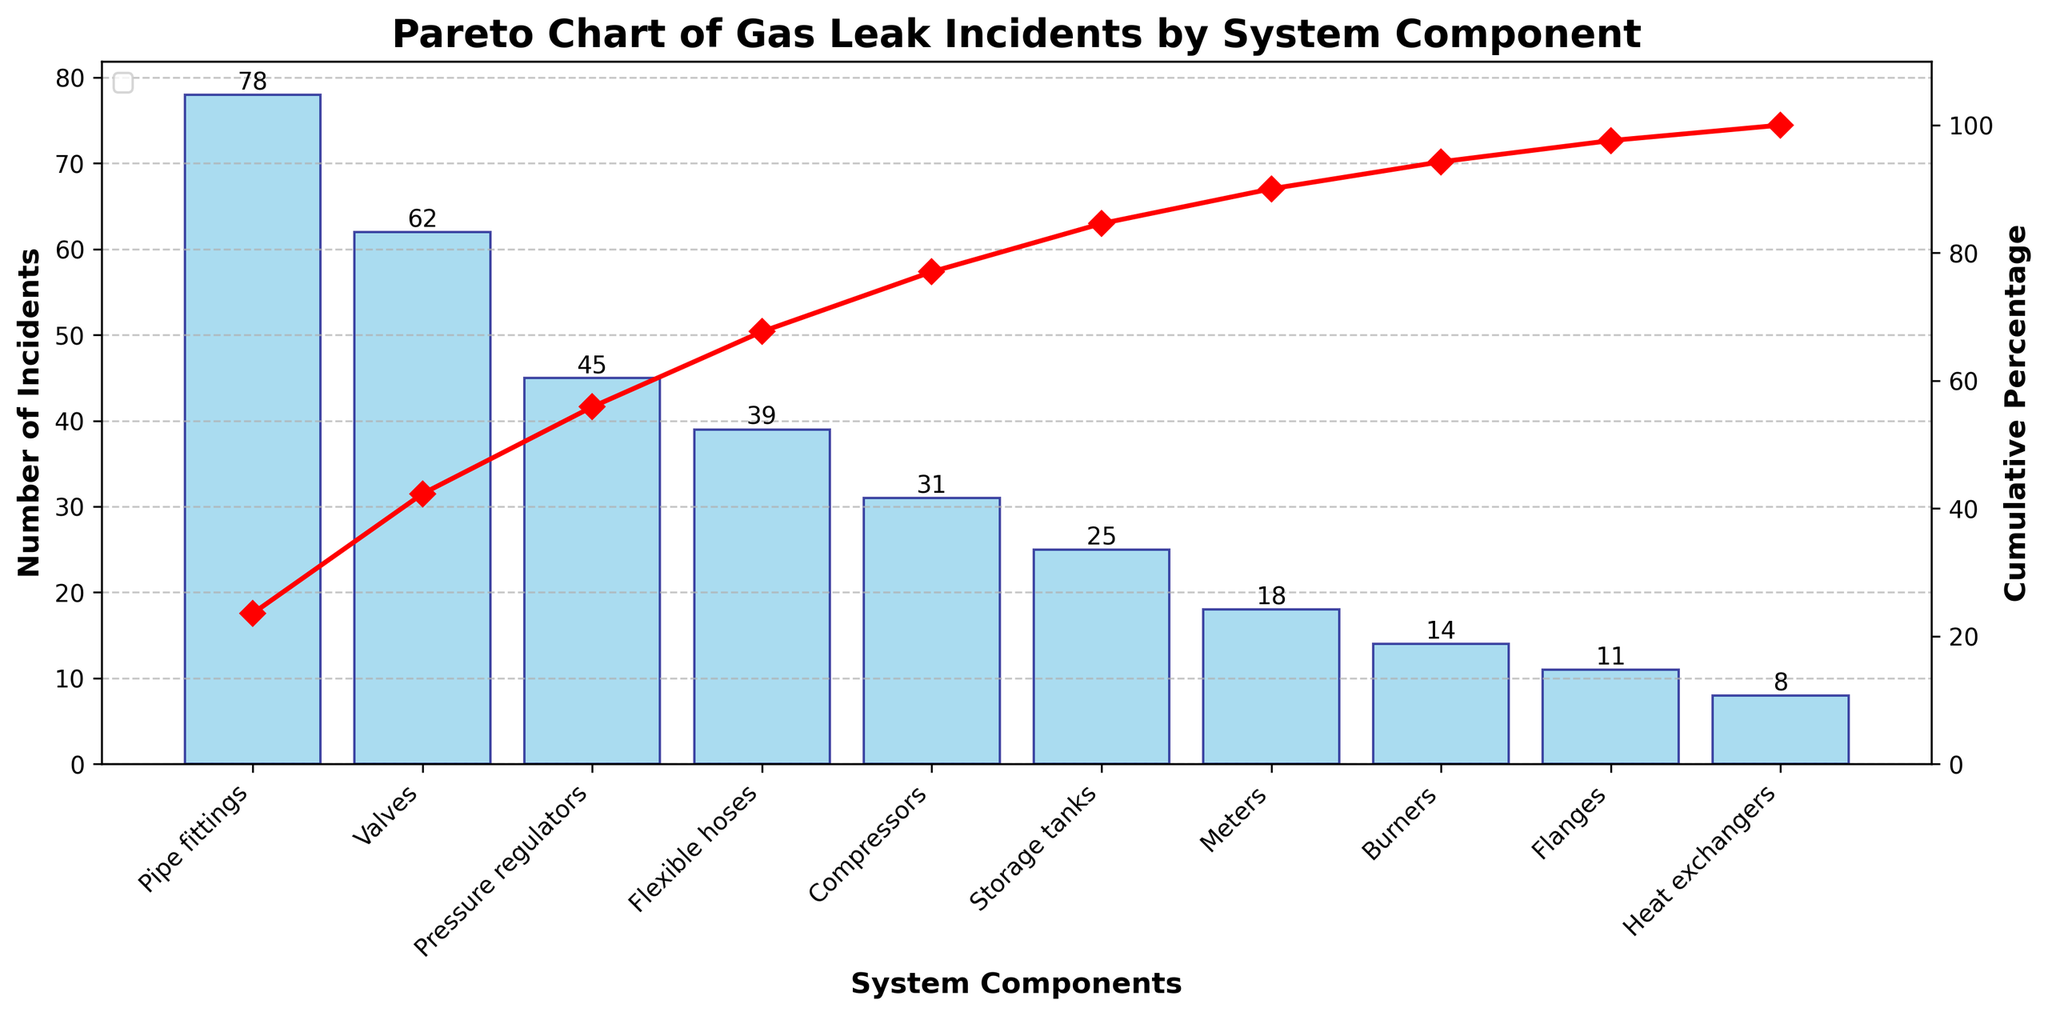What's the title of the chart? The title is usually displayed at the top of the chart. In this case, it reads "Pareto Chart of Gas Leak Incidents by System Component".
Answer: Pareto Chart of Gas Leak Incidents by System Component Which system component has the highest number of incidents? To find this, look at the highest bar in the bar chart. The bar representing "Pipe fittings" is the tallest.
Answer: Pipe fittings What is the number of incidents for Valves? Locate the bar for "Valves" on the x-axis and note the value at the top of the bar. It shows "62".
Answer: 62 What's the cumulative percentage after the third component? The cumulative percentage line shows the accumulation as each component is added. After the third component (Pressure regulators), the line shows approximately 74.3%.
Answer: 74.3% Are there more incidents in Flexible hoses than in Compressors? Compare the heights of the bars for "Flexible hoses" and "Compressors". The bar for "Flexible hoses" is taller, indicating more incidents.
Answer: Yes What percent of incidents do the top three components cover? The cumulative percentage after "Pressure regulators" (the third component) is around 74.3%, as indicated by the red line.
Answer: 74.3% How many incidents are there in total? Count the total number of incidents by summing the values of all bars: 78 + 62 + 45 + 39 + 31 + 25 + 18 + 14 + 11 + 8 = 331.
Answer: 331 Which component contributes the least to the number of incidents? The shortest bar represents the component with the least incidents. "Heat exchangers" has the shortest bar.
Answer: Heat exchangers What's the cumulative percentage for the top five components combined? Identify the cumulative percentage after the fifth component (Compressors). It is around 80.7%.
Answer: 80.7% How does the number of incidents for Storage tanks compare to that for Meters? Compare the heights of the bars for "Storage tanks" and "Meters". The bar for "Storage tanks" is taller, indicating more incidents.
Answer: Storage tanks have more incidents 